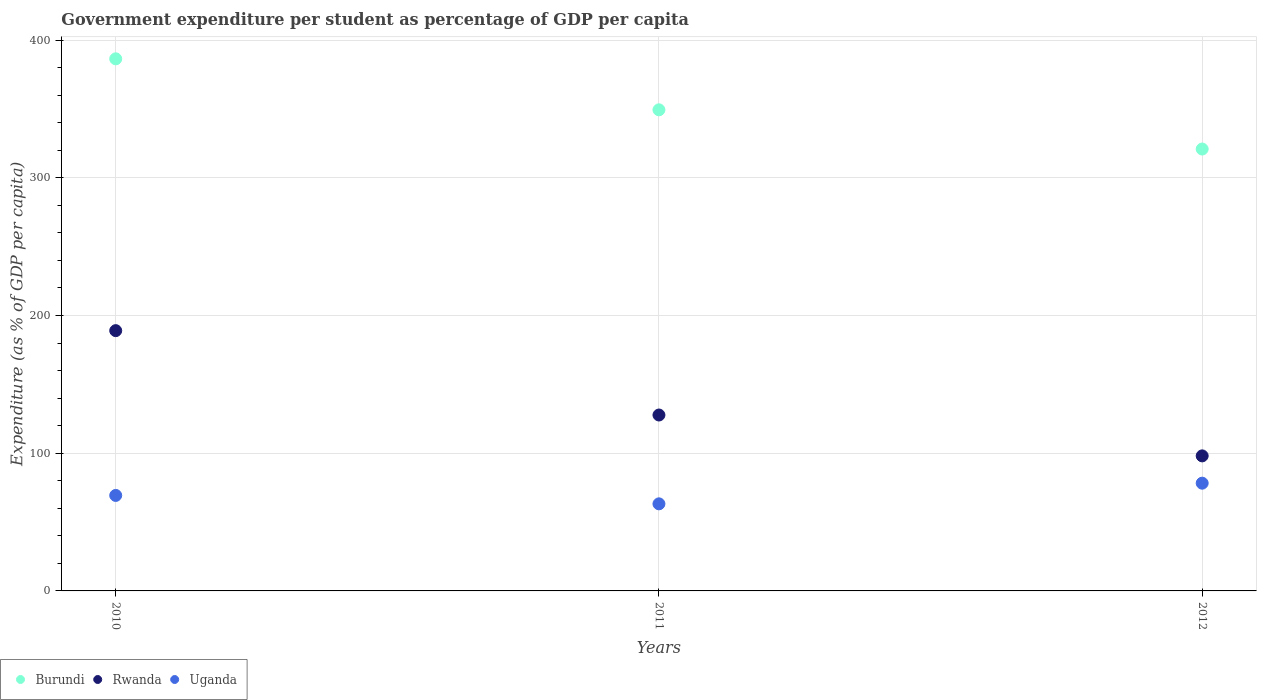How many different coloured dotlines are there?
Provide a succinct answer. 3. Is the number of dotlines equal to the number of legend labels?
Your answer should be compact. Yes. What is the percentage of expenditure per student in Rwanda in 2011?
Your answer should be compact. 127.75. Across all years, what is the maximum percentage of expenditure per student in Burundi?
Provide a succinct answer. 386.42. Across all years, what is the minimum percentage of expenditure per student in Burundi?
Your answer should be very brief. 320.91. In which year was the percentage of expenditure per student in Uganda maximum?
Make the answer very short. 2012. What is the total percentage of expenditure per student in Rwanda in the graph?
Provide a succinct answer. 414.84. What is the difference between the percentage of expenditure per student in Rwanda in 2010 and that in 2012?
Your response must be concise. 90.95. What is the difference between the percentage of expenditure per student in Burundi in 2012 and the percentage of expenditure per student in Rwanda in 2010?
Your response must be concise. 131.9. What is the average percentage of expenditure per student in Uganda per year?
Make the answer very short. 70.28. In the year 2012, what is the difference between the percentage of expenditure per student in Rwanda and percentage of expenditure per student in Burundi?
Give a very brief answer. -222.84. In how many years, is the percentage of expenditure per student in Burundi greater than 60 %?
Provide a short and direct response. 3. What is the ratio of the percentage of expenditure per student in Rwanda in 2011 to that in 2012?
Your answer should be compact. 1.3. What is the difference between the highest and the second highest percentage of expenditure per student in Burundi?
Your response must be concise. 37.03. What is the difference between the highest and the lowest percentage of expenditure per student in Uganda?
Ensure brevity in your answer.  15.01. Is the sum of the percentage of expenditure per student in Uganda in 2010 and 2011 greater than the maximum percentage of expenditure per student in Rwanda across all years?
Your response must be concise. No. Is the percentage of expenditure per student in Uganda strictly greater than the percentage of expenditure per student in Burundi over the years?
Your answer should be very brief. No. Are the values on the major ticks of Y-axis written in scientific E-notation?
Your answer should be compact. No. Where does the legend appear in the graph?
Your answer should be very brief. Bottom left. What is the title of the graph?
Provide a short and direct response. Government expenditure per student as percentage of GDP per capita. What is the label or title of the X-axis?
Ensure brevity in your answer.  Years. What is the label or title of the Y-axis?
Ensure brevity in your answer.  Expenditure (as % of GDP per capita). What is the Expenditure (as % of GDP per capita) in Burundi in 2010?
Make the answer very short. 386.42. What is the Expenditure (as % of GDP per capita) in Rwanda in 2010?
Offer a terse response. 189.02. What is the Expenditure (as % of GDP per capita) of Uganda in 2010?
Make the answer very short. 69.35. What is the Expenditure (as % of GDP per capita) in Burundi in 2011?
Offer a terse response. 349.39. What is the Expenditure (as % of GDP per capita) in Rwanda in 2011?
Offer a terse response. 127.75. What is the Expenditure (as % of GDP per capita) in Uganda in 2011?
Provide a short and direct response. 63.24. What is the Expenditure (as % of GDP per capita) in Burundi in 2012?
Provide a succinct answer. 320.91. What is the Expenditure (as % of GDP per capita) in Rwanda in 2012?
Make the answer very short. 98.07. What is the Expenditure (as % of GDP per capita) of Uganda in 2012?
Offer a terse response. 78.25. Across all years, what is the maximum Expenditure (as % of GDP per capita) of Burundi?
Your answer should be compact. 386.42. Across all years, what is the maximum Expenditure (as % of GDP per capita) in Rwanda?
Your answer should be compact. 189.02. Across all years, what is the maximum Expenditure (as % of GDP per capita) of Uganda?
Give a very brief answer. 78.25. Across all years, what is the minimum Expenditure (as % of GDP per capita) of Burundi?
Ensure brevity in your answer.  320.91. Across all years, what is the minimum Expenditure (as % of GDP per capita) in Rwanda?
Provide a short and direct response. 98.07. Across all years, what is the minimum Expenditure (as % of GDP per capita) of Uganda?
Your answer should be very brief. 63.24. What is the total Expenditure (as % of GDP per capita) of Burundi in the graph?
Ensure brevity in your answer.  1056.72. What is the total Expenditure (as % of GDP per capita) of Rwanda in the graph?
Provide a succinct answer. 414.84. What is the total Expenditure (as % of GDP per capita) in Uganda in the graph?
Offer a terse response. 210.83. What is the difference between the Expenditure (as % of GDP per capita) in Burundi in 2010 and that in 2011?
Your answer should be very brief. 37.03. What is the difference between the Expenditure (as % of GDP per capita) in Rwanda in 2010 and that in 2011?
Ensure brevity in your answer.  61.27. What is the difference between the Expenditure (as % of GDP per capita) in Uganda in 2010 and that in 2011?
Your answer should be very brief. 6.11. What is the difference between the Expenditure (as % of GDP per capita) in Burundi in 2010 and that in 2012?
Make the answer very short. 65.51. What is the difference between the Expenditure (as % of GDP per capita) in Rwanda in 2010 and that in 2012?
Provide a succinct answer. 90.95. What is the difference between the Expenditure (as % of GDP per capita) in Uganda in 2010 and that in 2012?
Provide a short and direct response. -8.9. What is the difference between the Expenditure (as % of GDP per capita) in Burundi in 2011 and that in 2012?
Make the answer very short. 28.47. What is the difference between the Expenditure (as % of GDP per capita) in Rwanda in 2011 and that in 2012?
Make the answer very short. 29.68. What is the difference between the Expenditure (as % of GDP per capita) of Uganda in 2011 and that in 2012?
Make the answer very short. -15.01. What is the difference between the Expenditure (as % of GDP per capita) of Burundi in 2010 and the Expenditure (as % of GDP per capita) of Rwanda in 2011?
Your answer should be compact. 258.67. What is the difference between the Expenditure (as % of GDP per capita) of Burundi in 2010 and the Expenditure (as % of GDP per capita) of Uganda in 2011?
Provide a succinct answer. 323.18. What is the difference between the Expenditure (as % of GDP per capita) of Rwanda in 2010 and the Expenditure (as % of GDP per capita) of Uganda in 2011?
Provide a short and direct response. 125.78. What is the difference between the Expenditure (as % of GDP per capita) in Burundi in 2010 and the Expenditure (as % of GDP per capita) in Rwanda in 2012?
Give a very brief answer. 288.35. What is the difference between the Expenditure (as % of GDP per capita) of Burundi in 2010 and the Expenditure (as % of GDP per capita) of Uganda in 2012?
Provide a succinct answer. 308.17. What is the difference between the Expenditure (as % of GDP per capita) of Rwanda in 2010 and the Expenditure (as % of GDP per capita) of Uganda in 2012?
Provide a short and direct response. 110.77. What is the difference between the Expenditure (as % of GDP per capita) in Burundi in 2011 and the Expenditure (as % of GDP per capita) in Rwanda in 2012?
Give a very brief answer. 251.32. What is the difference between the Expenditure (as % of GDP per capita) in Burundi in 2011 and the Expenditure (as % of GDP per capita) in Uganda in 2012?
Keep it short and to the point. 271.14. What is the difference between the Expenditure (as % of GDP per capita) in Rwanda in 2011 and the Expenditure (as % of GDP per capita) in Uganda in 2012?
Keep it short and to the point. 49.51. What is the average Expenditure (as % of GDP per capita) in Burundi per year?
Keep it short and to the point. 352.24. What is the average Expenditure (as % of GDP per capita) in Rwanda per year?
Ensure brevity in your answer.  138.28. What is the average Expenditure (as % of GDP per capita) of Uganda per year?
Ensure brevity in your answer.  70.28. In the year 2010, what is the difference between the Expenditure (as % of GDP per capita) of Burundi and Expenditure (as % of GDP per capita) of Rwanda?
Give a very brief answer. 197.4. In the year 2010, what is the difference between the Expenditure (as % of GDP per capita) of Burundi and Expenditure (as % of GDP per capita) of Uganda?
Make the answer very short. 317.07. In the year 2010, what is the difference between the Expenditure (as % of GDP per capita) of Rwanda and Expenditure (as % of GDP per capita) of Uganda?
Keep it short and to the point. 119.67. In the year 2011, what is the difference between the Expenditure (as % of GDP per capita) in Burundi and Expenditure (as % of GDP per capita) in Rwanda?
Provide a short and direct response. 221.63. In the year 2011, what is the difference between the Expenditure (as % of GDP per capita) of Burundi and Expenditure (as % of GDP per capita) of Uganda?
Your answer should be compact. 286.15. In the year 2011, what is the difference between the Expenditure (as % of GDP per capita) in Rwanda and Expenditure (as % of GDP per capita) in Uganda?
Provide a short and direct response. 64.51. In the year 2012, what is the difference between the Expenditure (as % of GDP per capita) of Burundi and Expenditure (as % of GDP per capita) of Rwanda?
Give a very brief answer. 222.84. In the year 2012, what is the difference between the Expenditure (as % of GDP per capita) of Burundi and Expenditure (as % of GDP per capita) of Uganda?
Your answer should be compact. 242.67. In the year 2012, what is the difference between the Expenditure (as % of GDP per capita) of Rwanda and Expenditure (as % of GDP per capita) of Uganda?
Your answer should be compact. 19.82. What is the ratio of the Expenditure (as % of GDP per capita) of Burundi in 2010 to that in 2011?
Provide a succinct answer. 1.11. What is the ratio of the Expenditure (as % of GDP per capita) of Rwanda in 2010 to that in 2011?
Ensure brevity in your answer.  1.48. What is the ratio of the Expenditure (as % of GDP per capita) in Uganda in 2010 to that in 2011?
Provide a short and direct response. 1.1. What is the ratio of the Expenditure (as % of GDP per capita) of Burundi in 2010 to that in 2012?
Offer a terse response. 1.2. What is the ratio of the Expenditure (as % of GDP per capita) of Rwanda in 2010 to that in 2012?
Provide a short and direct response. 1.93. What is the ratio of the Expenditure (as % of GDP per capita) of Uganda in 2010 to that in 2012?
Your answer should be compact. 0.89. What is the ratio of the Expenditure (as % of GDP per capita) of Burundi in 2011 to that in 2012?
Ensure brevity in your answer.  1.09. What is the ratio of the Expenditure (as % of GDP per capita) in Rwanda in 2011 to that in 2012?
Your answer should be compact. 1.3. What is the ratio of the Expenditure (as % of GDP per capita) of Uganda in 2011 to that in 2012?
Make the answer very short. 0.81. What is the difference between the highest and the second highest Expenditure (as % of GDP per capita) of Burundi?
Your response must be concise. 37.03. What is the difference between the highest and the second highest Expenditure (as % of GDP per capita) of Rwanda?
Ensure brevity in your answer.  61.27. What is the difference between the highest and the second highest Expenditure (as % of GDP per capita) in Uganda?
Keep it short and to the point. 8.9. What is the difference between the highest and the lowest Expenditure (as % of GDP per capita) of Burundi?
Make the answer very short. 65.51. What is the difference between the highest and the lowest Expenditure (as % of GDP per capita) of Rwanda?
Ensure brevity in your answer.  90.95. What is the difference between the highest and the lowest Expenditure (as % of GDP per capita) of Uganda?
Offer a very short reply. 15.01. 